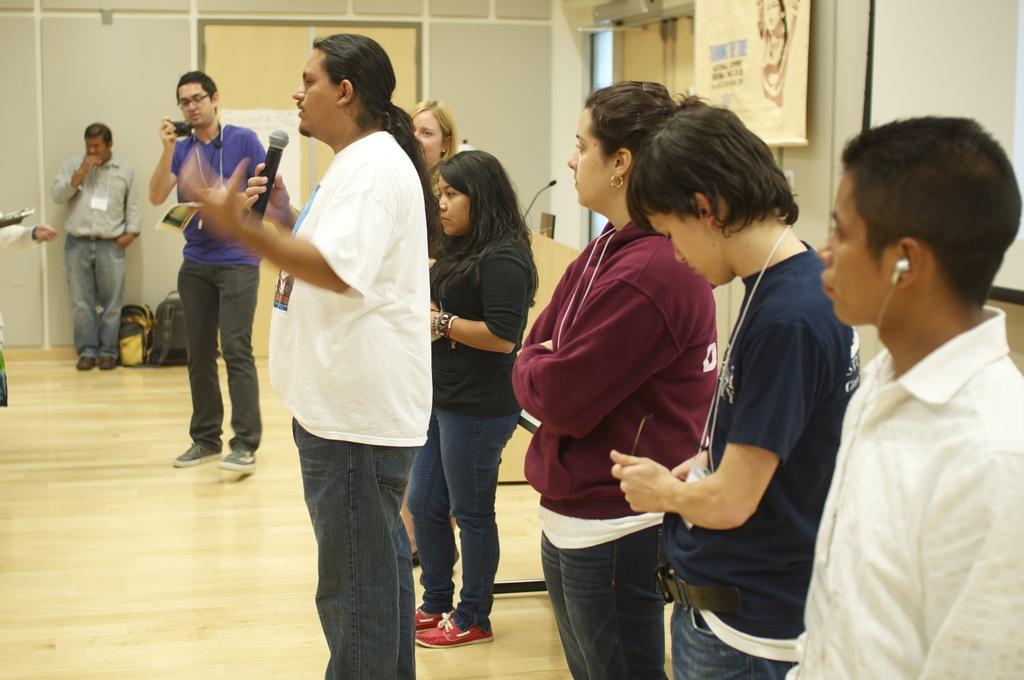Describe this image in one or two sentences. Here we can see few persons are standing on the floor and he is talking on the mike. There are bags, mike, and a poster. In the background we can see a wall. 